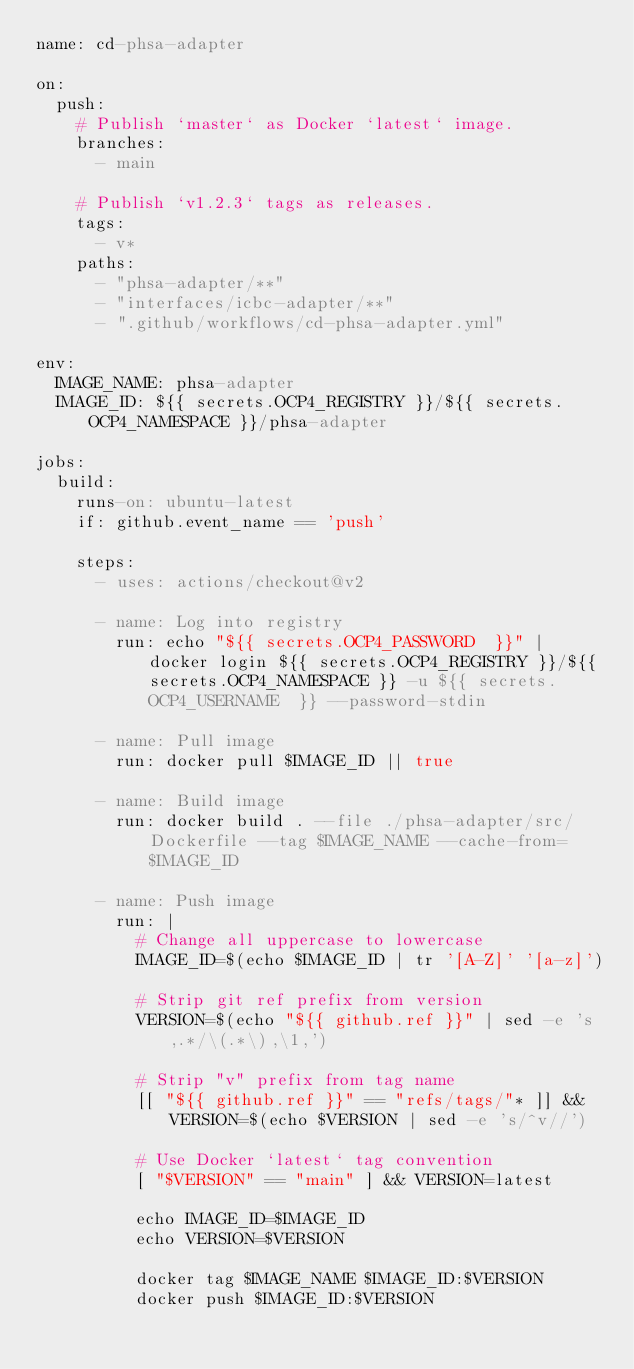<code> <loc_0><loc_0><loc_500><loc_500><_YAML_>name: cd-phsa-adapter

on:
  push:
    # Publish `master` as Docker `latest` image.
    branches:
      - main

    # Publish `v1.2.3` tags as releases.
    tags:
      - v*
    paths:    
      - "phsa-adapter/**"
      - "interfaces/icbc-adapter/**"
      - ".github/workflows/cd-phsa-adapter.yml"

env:
  IMAGE_NAME: phsa-adapter
  IMAGE_ID: ${{ secrets.OCP4_REGISTRY }}/${{ secrets.OCP4_NAMESPACE }}/phsa-adapter

jobs:
  build:
    runs-on: ubuntu-latest
    if: github.event_name == 'push'

    steps:
      - uses: actions/checkout@v2

      - name: Log into registry
        run: echo "${{ secrets.OCP4_PASSWORD  }}" | docker login ${{ secrets.OCP4_REGISTRY }}/${{ secrets.OCP4_NAMESPACE }} -u ${{ secrets.OCP4_USERNAME  }} --password-stdin

      - name: Pull image
        run: docker pull $IMAGE_ID || true

      - name: Build image
        run: docker build . --file ./phsa-adapter/src/Dockerfile --tag $IMAGE_NAME --cache-from=$IMAGE_ID 

      - name: Push image
        run: |
          # Change all uppercase to lowercase
          IMAGE_ID=$(echo $IMAGE_ID | tr '[A-Z]' '[a-z]')

          # Strip git ref prefix from version
          VERSION=$(echo "${{ github.ref }}" | sed -e 's,.*/\(.*\),\1,')

          # Strip "v" prefix from tag name
          [[ "${{ github.ref }}" == "refs/tags/"* ]] && VERSION=$(echo $VERSION | sed -e 's/^v//')

          # Use Docker `latest` tag convention
          [ "$VERSION" == "main" ] && VERSION=latest

          echo IMAGE_ID=$IMAGE_ID
          echo VERSION=$VERSION

          docker tag $IMAGE_NAME $IMAGE_ID:$VERSION
          docker push $IMAGE_ID:$VERSION
</code> 